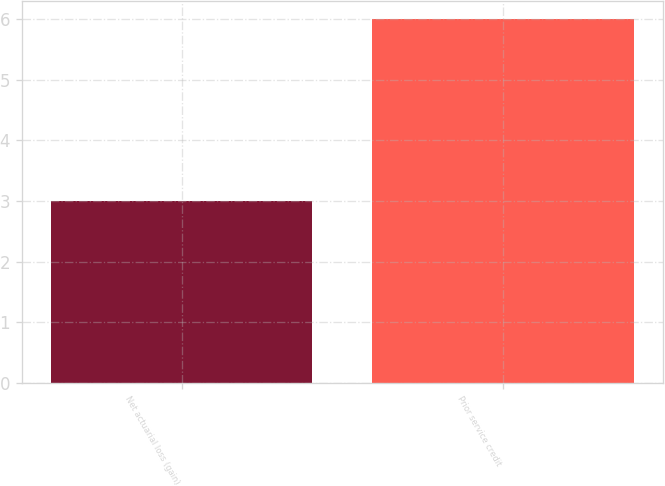Convert chart to OTSL. <chart><loc_0><loc_0><loc_500><loc_500><bar_chart><fcel>Net actuarial loss (gain)<fcel>Prior service credit<nl><fcel>3<fcel>6<nl></chart> 